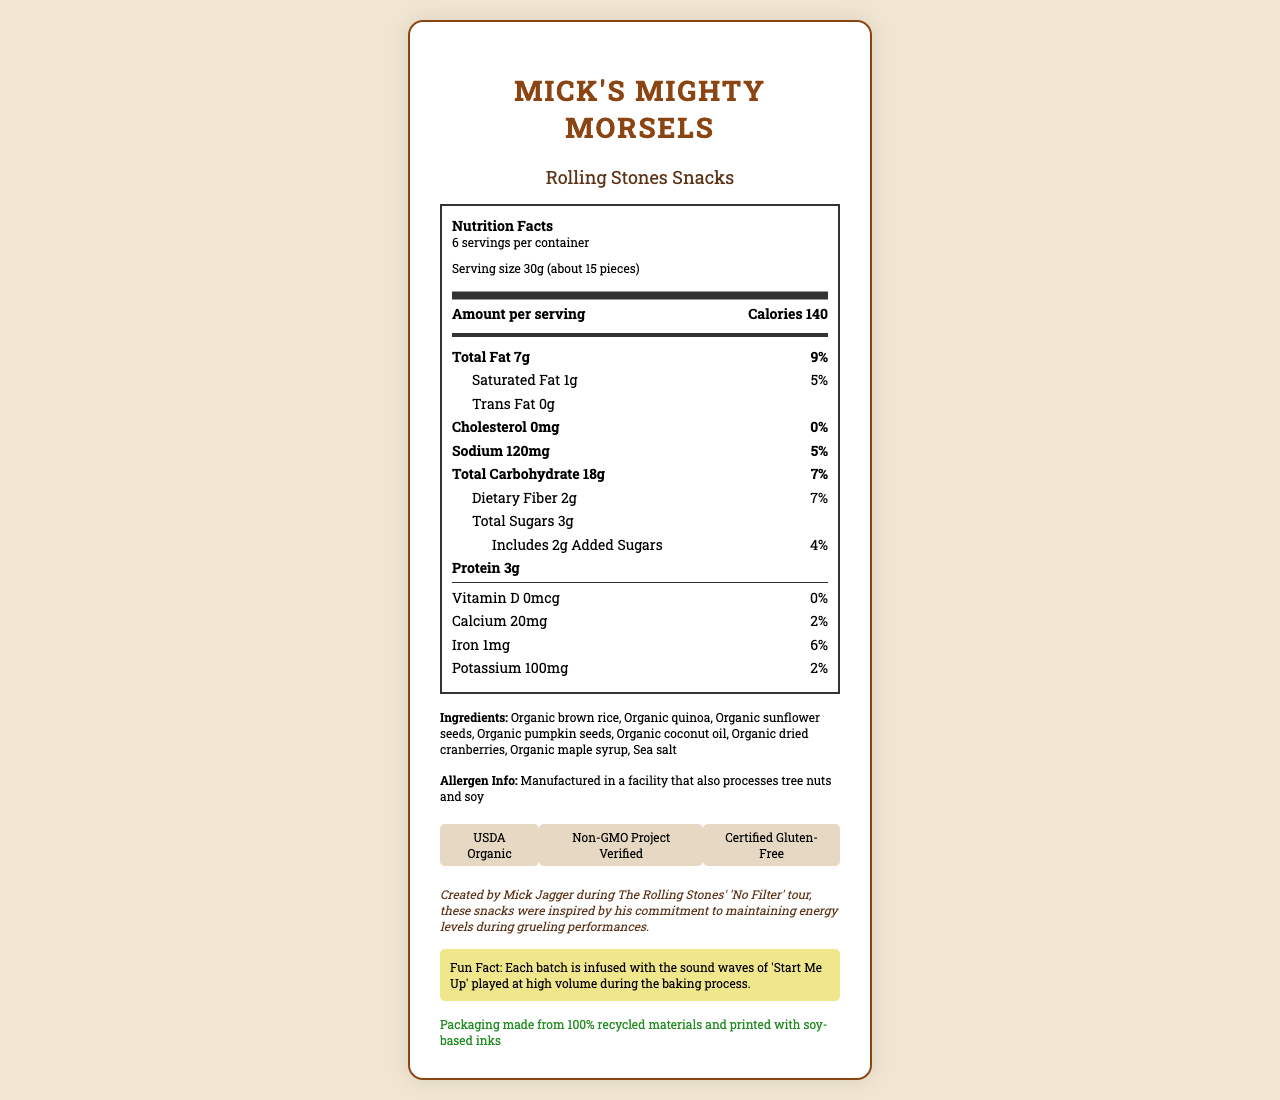what is the product name? The product name is clearly shown at the top of the document.
Answer: Mick's Mighty Morsels who is the brand behind this snack? The brand is displayed directly below the product name in the document.
Answer: Rolling Stones Snacks what is the serving size in grams? The serving size is shown as "30g (about 15 pieces)" in the serving information section.
Answer: 30g how many servings are there per container? The document states that there are 6 servings per container.
Answer: 6 how many calories are in each serving? The amount of calories per serving is displayed as 140 calories.
Answer: 140 how much total fat is in one serving? The total fat content per serving is listed as 7g.
Answer: 7g what percentage of daily value does total fat contribute? The document states that total fat contributes 9% of the daily value.
Answer: 9% how much protein is there in a single serving? The protein content per serving is 3g.
Answer: 3g which of the following certifications does Mick's Mighty Morsels have? A. Certified Kosher B. USDA Organic C. Fair Trade Certified D. Whole30 Approved The document lists USDA Organic as one of the certifications.
Answer: B. USDA Organic what kind of packaging materials are used? A. Plastic B. Recycled materials C. Glass D. Aluminum The sustainability section mentions that the packaging is made from 100% recycled materials.
Answer: B. Recycled materials is the snack manufactured in a facility that processes tree nuts and soy? The allergen information states that the snack is manufactured in a facility that also processes tree nuts and soy.
Answer: Yes how much dietary fiber is in one serving? The dietary fiber content per serving is shown as 2g.
Answer: 2g how many milligrams of potassium are in each serving? The potassium content per serving is marked as 100mg.
Answer: 100mg does this product contain any cholesterol? The document states that there is 0mg of cholesterol, which means the product contains no cholesterol.
Answer: No what are the added sugars per serving, and what percentage of the daily value do they contribute? The added sugars per serving are 2g, and they contribute 4% of the daily value.
Answer: 2g, 4% what inspired the creation of these snacks? The backstory section explains that the snacks were inspired by Mick Jagger's need for energy during the tour.
Answer: Mick Jagger's commitment to maintaining energy levels during the 'No Filter' tour how many milligrams of calcium are in one serving? The calcium content per serving is 20mg, as shown in the document.
Answer: 20mg describe the main idea of the document. The document mainly describes the nutritional facts and key points about Mick's Mighty Morsels snack, created by Mick Jagger, along with other relevant product information.
Answer: The document provides the nutritional information about an organic, gluten-free snack called Mick's Mighty Morsels, created by Mick Jagger and branded under Rolling Stones Snacks. It details the serving size, calorie content, various nutrients, ingredients, allergen information, certifications, and a backstory about the product's creation. Additionally, it highlights a fun fact and sustainability information about the packaging. what is the net weight of the entire package? The document provides information on individual serving sizes and the number of servings per container but does not directly state the total net weight of the package.
Answer: Not enough information 